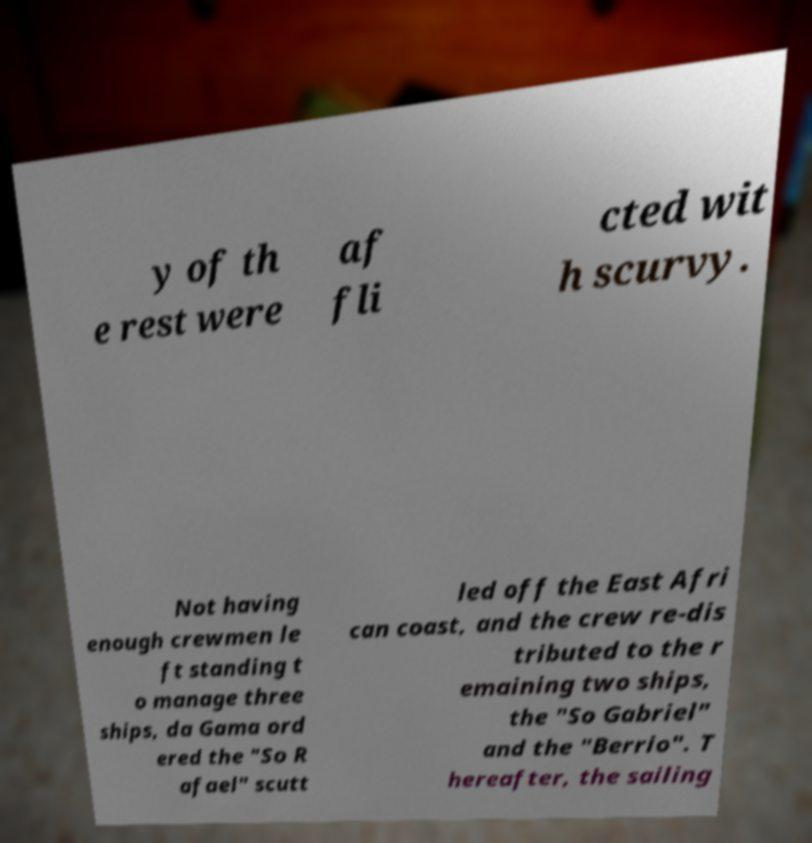What messages or text are displayed in this image? I need them in a readable, typed format. y of th e rest were af fli cted wit h scurvy. Not having enough crewmen le ft standing t o manage three ships, da Gama ord ered the "So R afael" scutt led off the East Afri can coast, and the crew re-dis tributed to the r emaining two ships, the "So Gabriel" and the "Berrio". T hereafter, the sailing 